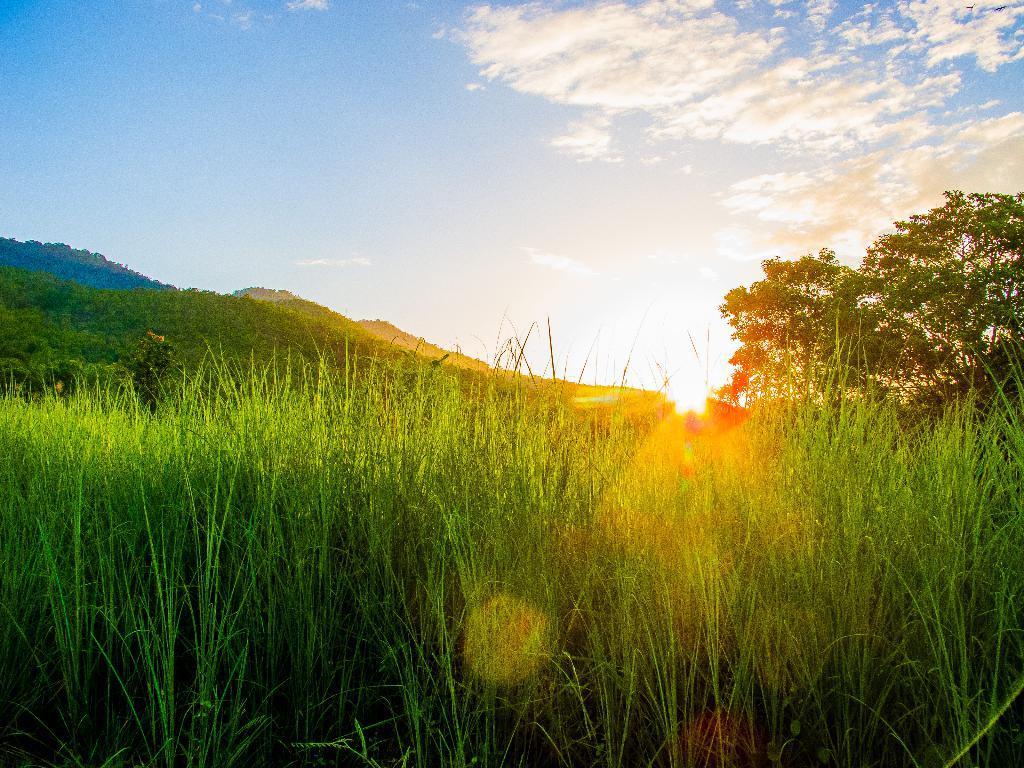Could you give a brief overview of what you see in this image? In this picture we can see some grass from left to right. There are few trees on the right side. Some greenery is visible on the left side. We can see sun rays in the background. Sky is blue in color and cloudy. 